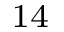Convert formula to latex. <formula><loc_0><loc_0><loc_500><loc_500>^ { 1 4 }</formula> 